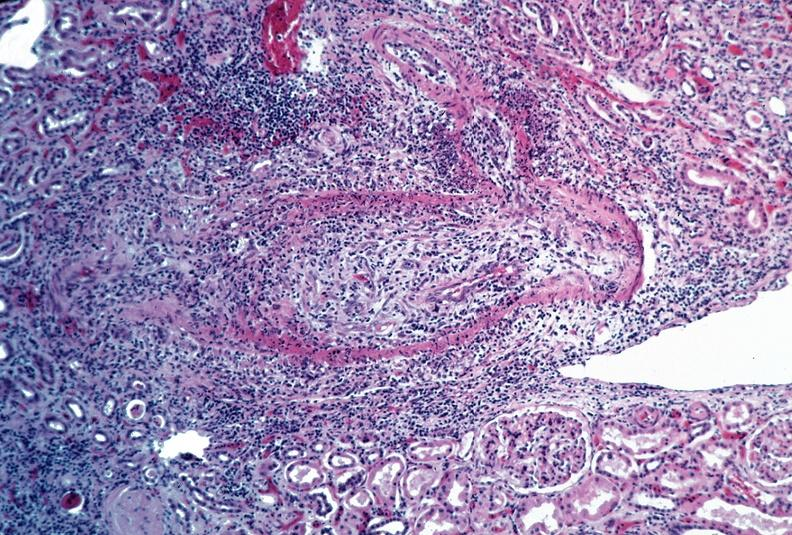what is present?
Answer the question using a single word or phrase. Vasculature 